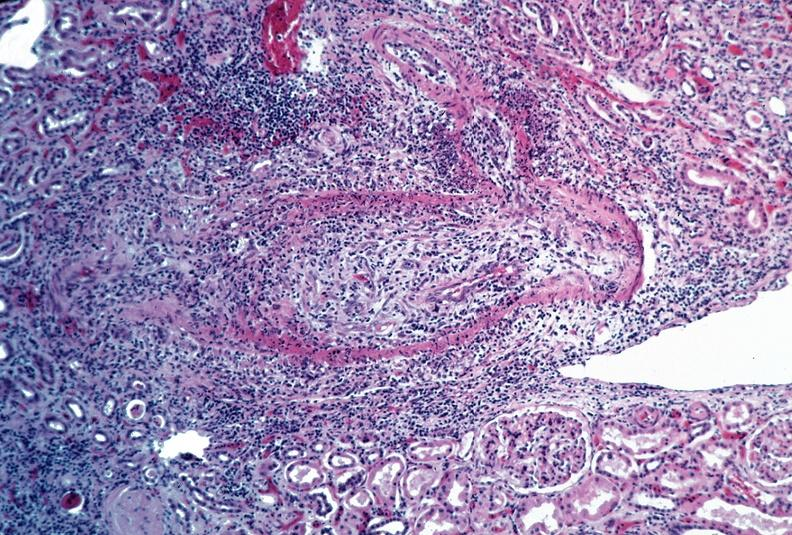what is present?
Answer the question using a single word or phrase. Vasculature 